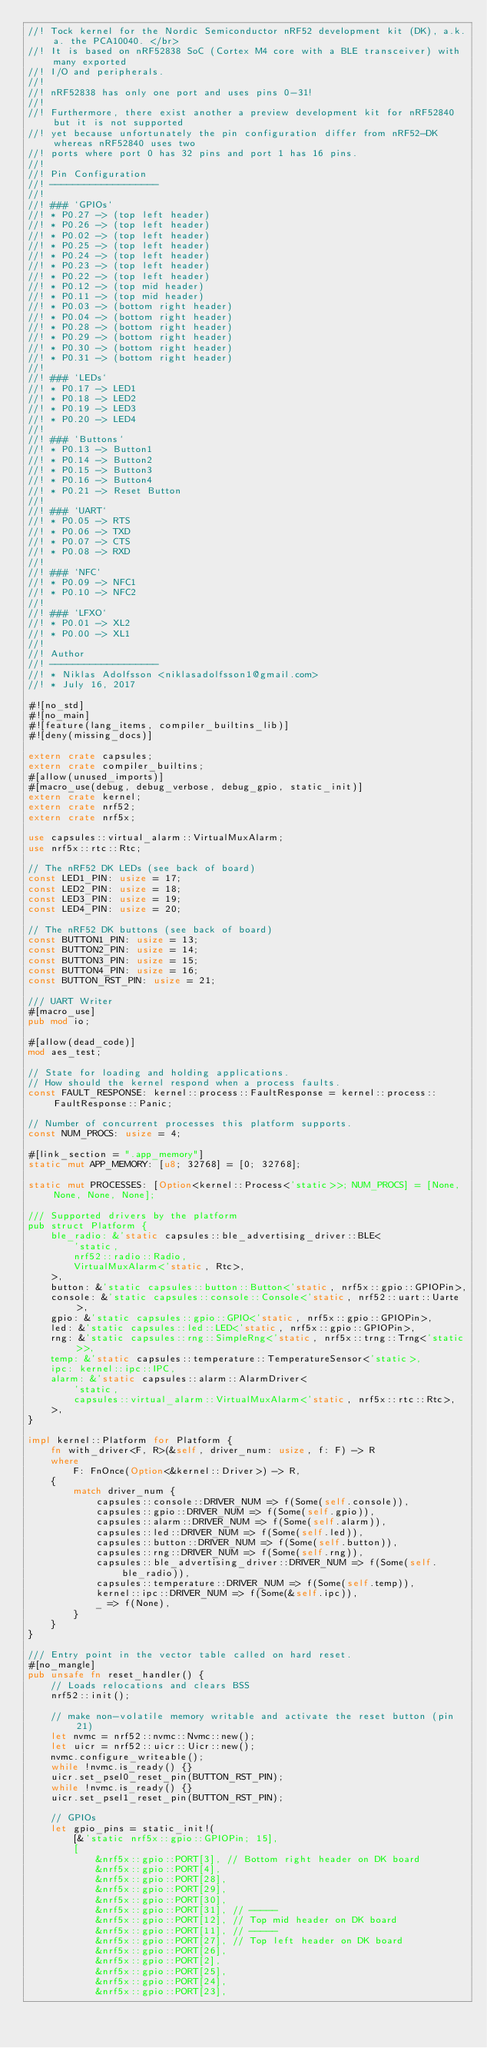<code> <loc_0><loc_0><loc_500><loc_500><_Rust_>//! Tock kernel for the Nordic Semiconductor nRF52 development kit (DK), a.k.a. the PCA10040. </br>
//! It is based on nRF52838 SoC (Cortex M4 core with a BLE transceiver) with many exported
//! I/O and peripherals.
//!
//! nRF52838 has only one port and uses pins 0-31!
//!
//! Furthermore, there exist another a preview development kit for nRF52840 but it is not supported
//! yet because unfortunately the pin configuration differ from nRF52-DK whereas nRF52840 uses two
//! ports where port 0 has 32 pins and port 1 has 16 pins.
//!
//! Pin Configuration
//! -------------------
//!
//! ### `GPIOs`
//! * P0.27 -> (top left header)
//! * P0.26 -> (top left header)
//! * P0.02 -> (top left header)
//! * P0.25 -> (top left header)
//! * P0.24 -> (top left header)
//! * P0.23 -> (top left header)
//! * P0.22 -> (top left header)
//! * P0.12 -> (top mid header)
//! * P0.11 -> (top mid header)
//! * P0.03 -> (bottom right header)
//! * P0.04 -> (bottom right header)
//! * P0.28 -> (bottom right header)
//! * P0.29 -> (bottom right header)
//! * P0.30 -> (bottom right header)
//! * P0.31 -> (bottom right header)
//!
//! ### `LEDs`
//! * P0.17 -> LED1
//! * P0.18 -> LED2
//! * P0.19 -> LED3
//! * P0.20 -> LED4
//!
//! ### `Buttons`
//! * P0.13 -> Button1
//! * P0.14 -> Button2
//! * P0.15 -> Button3
//! * P0.16 -> Button4
//! * P0.21 -> Reset Button
//!
//! ### `UART`
//! * P0.05 -> RTS
//! * P0.06 -> TXD
//! * P0.07 -> CTS
//! * P0.08 -> RXD
//!
//! ### `NFC`
//! * P0.09 -> NFC1
//! * P0.10 -> NFC2
//!
//! ### `LFXO`
//! * P0.01 -> XL2
//! * P0.00 -> XL1
//!
//! Author
//! -------------------
//! * Niklas Adolfsson <niklasadolfsson1@gmail.com>
//! * July 16, 2017

#![no_std]
#![no_main]
#![feature(lang_items, compiler_builtins_lib)]
#![deny(missing_docs)]

extern crate capsules;
extern crate compiler_builtins;
#[allow(unused_imports)]
#[macro_use(debug, debug_verbose, debug_gpio, static_init)]
extern crate kernel;
extern crate nrf52;
extern crate nrf5x;

use capsules::virtual_alarm::VirtualMuxAlarm;
use nrf5x::rtc::Rtc;

// The nRF52 DK LEDs (see back of board)
const LED1_PIN: usize = 17;
const LED2_PIN: usize = 18;
const LED3_PIN: usize = 19;
const LED4_PIN: usize = 20;

// The nRF52 DK buttons (see back of board)
const BUTTON1_PIN: usize = 13;
const BUTTON2_PIN: usize = 14;
const BUTTON3_PIN: usize = 15;
const BUTTON4_PIN: usize = 16;
const BUTTON_RST_PIN: usize = 21;

/// UART Writer
#[macro_use]
pub mod io;

#[allow(dead_code)]
mod aes_test;

// State for loading and holding applications.
// How should the kernel respond when a process faults.
const FAULT_RESPONSE: kernel::process::FaultResponse = kernel::process::FaultResponse::Panic;

// Number of concurrent processes this platform supports.
const NUM_PROCS: usize = 4;

#[link_section = ".app_memory"]
static mut APP_MEMORY: [u8; 32768] = [0; 32768];

static mut PROCESSES: [Option<kernel::Process<'static>>; NUM_PROCS] = [None, None, None, None];

/// Supported drivers by the platform
pub struct Platform {
    ble_radio: &'static capsules::ble_advertising_driver::BLE<
        'static,
        nrf52::radio::Radio,
        VirtualMuxAlarm<'static, Rtc>,
    >,
    button: &'static capsules::button::Button<'static, nrf5x::gpio::GPIOPin>,
    console: &'static capsules::console::Console<'static, nrf52::uart::Uarte>,
    gpio: &'static capsules::gpio::GPIO<'static, nrf5x::gpio::GPIOPin>,
    led: &'static capsules::led::LED<'static, nrf5x::gpio::GPIOPin>,
    rng: &'static capsules::rng::SimpleRng<'static, nrf5x::trng::Trng<'static>>,
    temp: &'static capsules::temperature::TemperatureSensor<'static>,
    ipc: kernel::ipc::IPC,
    alarm: &'static capsules::alarm::AlarmDriver<
        'static,
        capsules::virtual_alarm::VirtualMuxAlarm<'static, nrf5x::rtc::Rtc>,
    >,
}

impl kernel::Platform for Platform {
    fn with_driver<F, R>(&self, driver_num: usize, f: F) -> R
    where
        F: FnOnce(Option<&kernel::Driver>) -> R,
    {
        match driver_num {
            capsules::console::DRIVER_NUM => f(Some(self.console)),
            capsules::gpio::DRIVER_NUM => f(Some(self.gpio)),
            capsules::alarm::DRIVER_NUM => f(Some(self.alarm)),
            capsules::led::DRIVER_NUM => f(Some(self.led)),
            capsules::button::DRIVER_NUM => f(Some(self.button)),
            capsules::rng::DRIVER_NUM => f(Some(self.rng)),
            capsules::ble_advertising_driver::DRIVER_NUM => f(Some(self.ble_radio)),
            capsules::temperature::DRIVER_NUM => f(Some(self.temp)),
            kernel::ipc::DRIVER_NUM => f(Some(&self.ipc)),
            _ => f(None),
        }
    }
}

/// Entry point in the vector table called on hard reset.
#[no_mangle]
pub unsafe fn reset_handler() {
    // Loads relocations and clears BSS
    nrf52::init();

    // make non-volatile memory writable and activate the reset button (pin 21)
    let nvmc = nrf52::nvmc::Nvmc::new();
    let uicr = nrf52::uicr::Uicr::new();
    nvmc.configure_writeable();
    while !nvmc.is_ready() {}
    uicr.set_psel0_reset_pin(BUTTON_RST_PIN);
    while !nvmc.is_ready() {}
    uicr.set_psel1_reset_pin(BUTTON_RST_PIN);

    // GPIOs
    let gpio_pins = static_init!(
        [&'static nrf5x::gpio::GPIOPin; 15],
        [
            &nrf5x::gpio::PORT[3], // Bottom right header on DK board
            &nrf5x::gpio::PORT[4],
            &nrf5x::gpio::PORT[28],
            &nrf5x::gpio::PORT[29],
            &nrf5x::gpio::PORT[30],
            &nrf5x::gpio::PORT[31], // -----
            &nrf5x::gpio::PORT[12], // Top mid header on DK board
            &nrf5x::gpio::PORT[11], // -----
            &nrf5x::gpio::PORT[27], // Top left header on DK board
            &nrf5x::gpio::PORT[26],
            &nrf5x::gpio::PORT[2],
            &nrf5x::gpio::PORT[25],
            &nrf5x::gpio::PORT[24],
            &nrf5x::gpio::PORT[23],</code> 